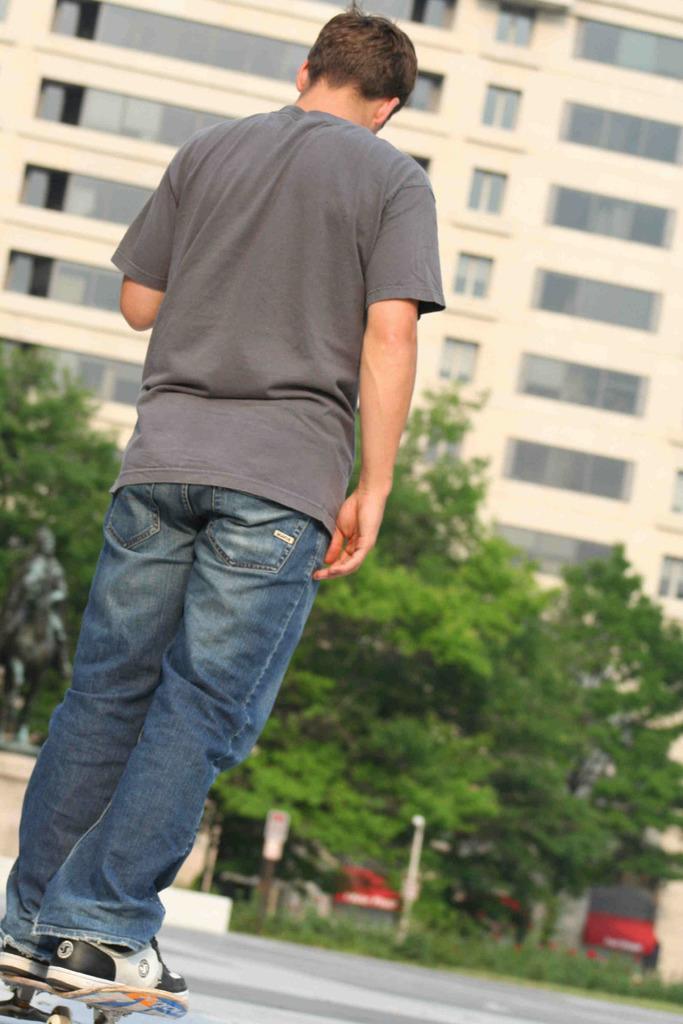How would you summarize this image in a sentence or two? There is a man standing on skateboard. Background we can see trees,buildings and grass. 